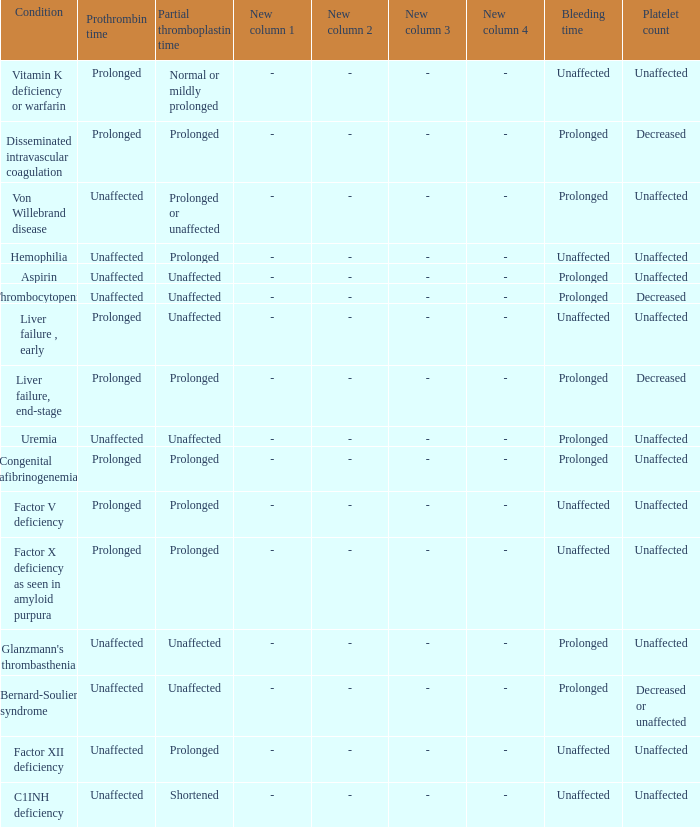Which Bleeding has a Condition of congenital afibrinogenemia? Prolonged. 